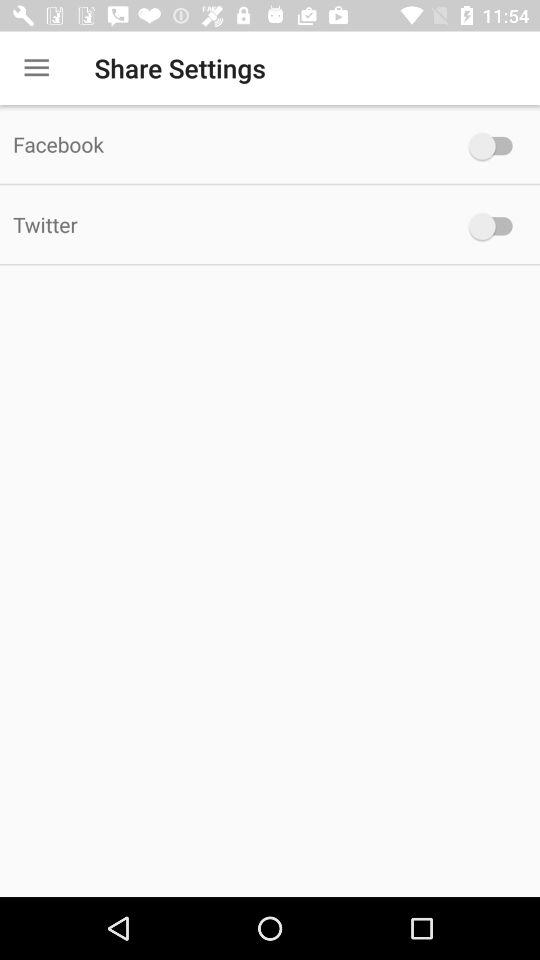What is the status of "Twitter"? The status of "Twitter" is off. 